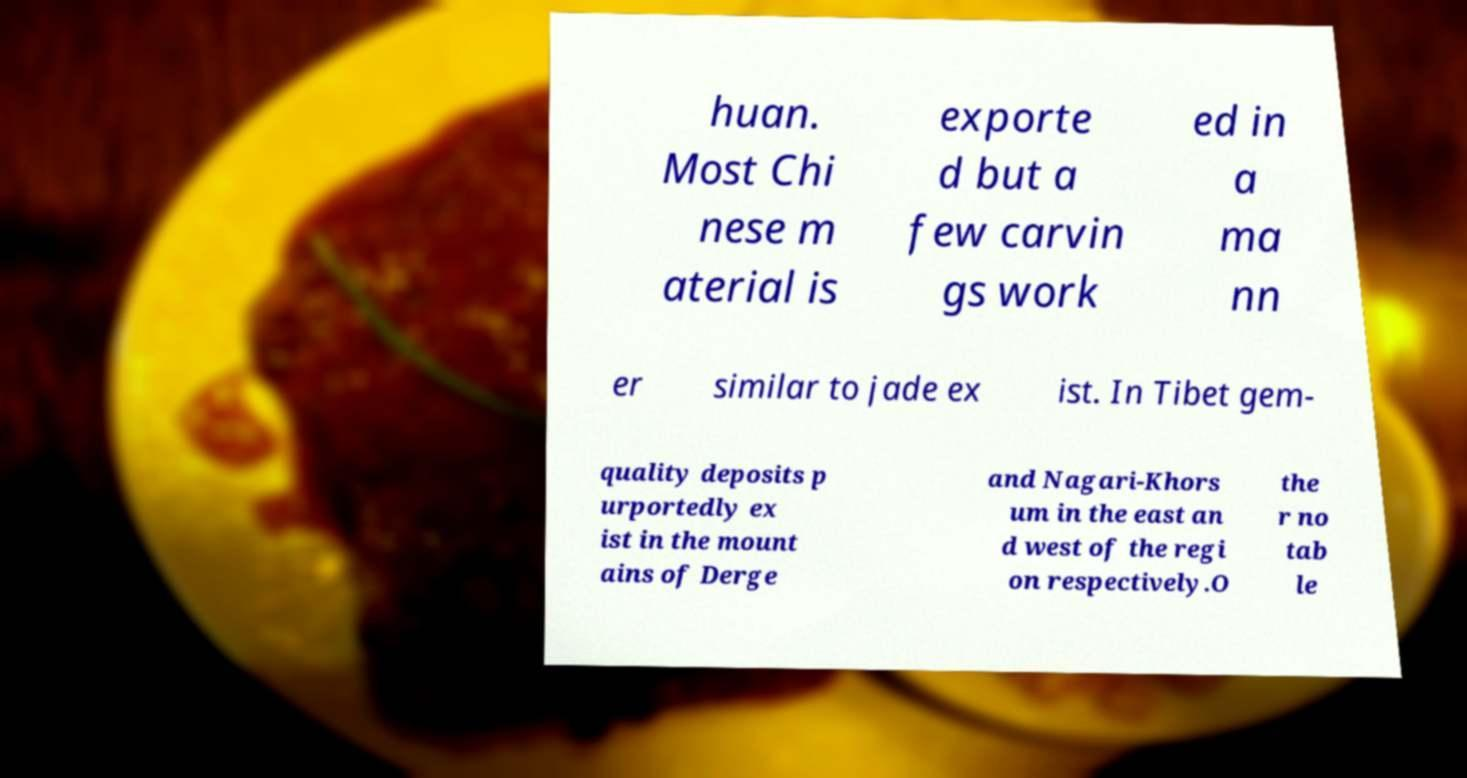What messages or text are displayed in this image? I need them in a readable, typed format. huan. Most Chi nese m aterial is exporte d but a few carvin gs work ed in a ma nn er similar to jade ex ist. In Tibet gem- quality deposits p urportedly ex ist in the mount ains of Derge and Nagari-Khors um in the east an d west of the regi on respectively.O the r no tab le 